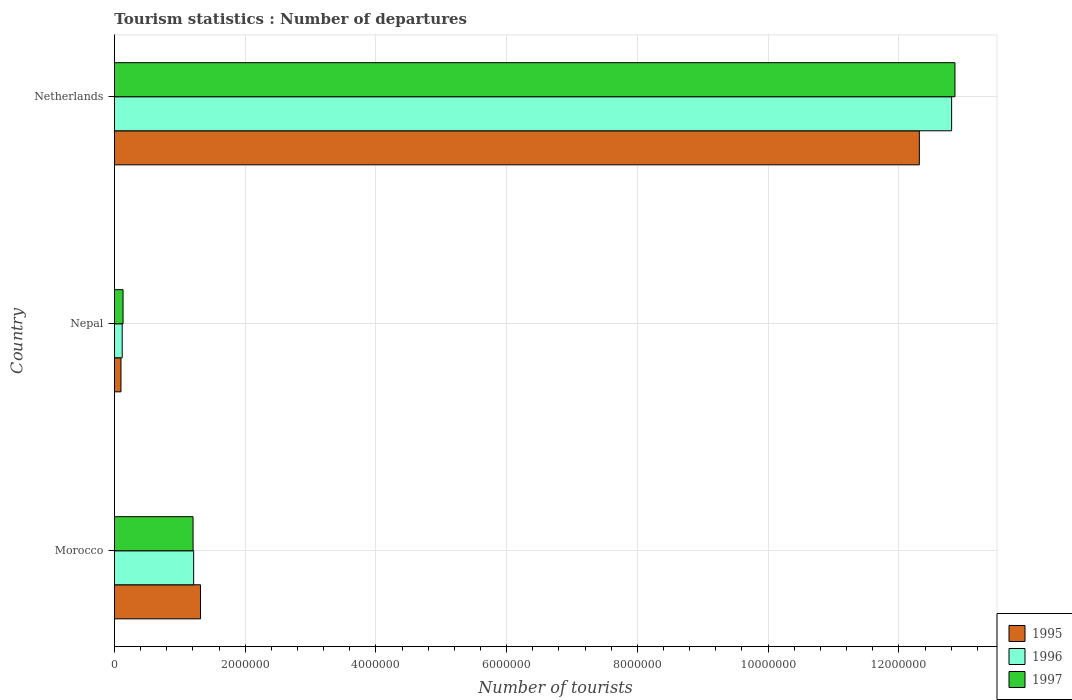Are the number of bars per tick equal to the number of legend labels?
Ensure brevity in your answer.  Yes. Are the number of bars on each tick of the Y-axis equal?
Offer a very short reply. Yes. What is the label of the 3rd group of bars from the top?
Provide a succinct answer. Morocco. In how many cases, is the number of bars for a given country not equal to the number of legend labels?
Provide a succinct answer. 0. What is the number of tourist departures in 1997 in Nepal?
Your answer should be compact. 1.32e+05. Across all countries, what is the maximum number of tourist departures in 1995?
Give a very brief answer. 1.23e+07. Across all countries, what is the minimum number of tourist departures in 1997?
Make the answer very short. 1.32e+05. In which country was the number of tourist departures in 1995 minimum?
Give a very brief answer. Nepal. What is the total number of tourist departures in 1996 in the graph?
Give a very brief answer. 1.41e+07. What is the difference between the number of tourist departures in 1997 in Morocco and that in Netherlands?
Give a very brief answer. -1.17e+07. What is the difference between the number of tourist departures in 1997 in Nepal and the number of tourist departures in 1995 in Morocco?
Provide a short and direct response. -1.18e+06. What is the average number of tourist departures in 1995 per country?
Provide a succinct answer. 4.58e+06. What is the difference between the number of tourist departures in 1996 and number of tourist departures in 1995 in Netherlands?
Ensure brevity in your answer.  4.94e+05. In how many countries, is the number of tourist departures in 1997 greater than 10800000 ?
Give a very brief answer. 1. What is the ratio of the number of tourist departures in 1996 in Nepal to that in Netherlands?
Keep it short and to the point. 0.01. Is the number of tourist departures in 1996 in Nepal less than that in Netherlands?
Offer a terse response. Yes. What is the difference between the highest and the second highest number of tourist departures in 1995?
Ensure brevity in your answer.  1.10e+07. What is the difference between the highest and the lowest number of tourist departures in 1996?
Offer a very short reply. 1.27e+07. In how many countries, is the number of tourist departures in 1996 greater than the average number of tourist departures in 1996 taken over all countries?
Keep it short and to the point. 1. What does the 3rd bar from the top in Nepal represents?
Offer a terse response. 1995. How many bars are there?
Provide a short and direct response. 9. Are the values on the major ticks of X-axis written in scientific E-notation?
Offer a very short reply. No. Does the graph contain any zero values?
Make the answer very short. No. Does the graph contain grids?
Your response must be concise. Yes. Where does the legend appear in the graph?
Your response must be concise. Bottom right. How many legend labels are there?
Ensure brevity in your answer.  3. What is the title of the graph?
Offer a terse response. Tourism statistics : Number of departures. What is the label or title of the X-axis?
Your response must be concise. Number of tourists. What is the label or title of the Y-axis?
Offer a terse response. Country. What is the Number of tourists of 1995 in Morocco?
Offer a very short reply. 1.32e+06. What is the Number of tourists in 1996 in Morocco?
Provide a succinct answer. 1.21e+06. What is the Number of tourists of 1997 in Morocco?
Offer a terse response. 1.20e+06. What is the Number of tourists of 1995 in Nepal?
Your response must be concise. 1.00e+05. What is the Number of tourists of 1996 in Nepal?
Your answer should be very brief. 1.19e+05. What is the Number of tourists of 1997 in Nepal?
Your answer should be compact. 1.32e+05. What is the Number of tourists in 1995 in Netherlands?
Provide a short and direct response. 1.23e+07. What is the Number of tourists in 1996 in Netherlands?
Provide a short and direct response. 1.28e+07. What is the Number of tourists in 1997 in Netherlands?
Give a very brief answer. 1.29e+07. Across all countries, what is the maximum Number of tourists in 1995?
Ensure brevity in your answer.  1.23e+07. Across all countries, what is the maximum Number of tourists of 1996?
Provide a succinct answer. 1.28e+07. Across all countries, what is the maximum Number of tourists of 1997?
Offer a very short reply. 1.29e+07. Across all countries, what is the minimum Number of tourists in 1996?
Offer a terse response. 1.19e+05. Across all countries, what is the minimum Number of tourists in 1997?
Provide a succinct answer. 1.32e+05. What is the total Number of tourists in 1995 in the graph?
Keep it short and to the point. 1.37e+07. What is the total Number of tourists in 1996 in the graph?
Your answer should be very brief. 1.41e+07. What is the total Number of tourists of 1997 in the graph?
Your answer should be very brief. 1.42e+07. What is the difference between the Number of tourists in 1995 in Morocco and that in Nepal?
Provide a succinct answer. 1.22e+06. What is the difference between the Number of tourists in 1996 in Morocco and that in Nepal?
Keep it short and to the point. 1.09e+06. What is the difference between the Number of tourists in 1997 in Morocco and that in Nepal?
Your response must be concise. 1.07e+06. What is the difference between the Number of tourists of 1995 in Morocco and that in Netherlands?
Your response must be concise. -1.10e+07. What is the difference between the Number of tourists in 1996 in Morocco and that in Netherlands?
Provide a succinct answer. -1.16e+07. What is the difference between the Number of tourists of 1997 in Morocco and that in Netherlands?
Your answer should be very brief. -1.17e+07. What is the difference between the Number of tourists of 1995 in Nepal and that in Netherlands?
Give a very brief answer. -1.22e+07. What is the difference between the Number of tourists in 1996 in Nepal and that in Netherlands?
Your answer should be compact. -1.27e+07. What is the difference between the Number of tourists of 1997 in Nepal and that in Netherlands?
Provide a succinct answer. -1.27e+07. What is the difference between the Number of tourists of 1995 in Morocco and the Number of tourists of 1996 in Nepal?
Provide a short and direct response. 1.20e+06. What is the difference between the Number of tourists in 1995 in Morocco and the Number of tourists in 1997 in Nepal?
Provide a short and direct response. 1.18e+06. What is the difference between the Number of tourists of 1996 in Morocco and the Number of tourists of 1997 in Nepal?
Your answer should be very brief. 1.08e+06. What is the difference between the Number of tourists of 1995 in Morocco and the Number of tourists of 1996 in Netherlands?
Offer a terse response. -1.15e+07. What is the difference between the Number of tourists of 1995 in Morocco and the Number of tourists of 1997 in Netherlands?
Offer a terse response. -1.15e+07. What is the difference between the Number of tourists of 1996 in Morocco and the Number of tourists of 1997 in Netherlands?
Your response must be concise. -1.16e+07. What is the difference between the Number of tourists of 1995 in Nepal and the Number of tourists of 1996 in Netherlands?
Your response must be concise. -1.27e+07. What is the difference between the Number of tourists in 1995 in Nepal and the Number of tourists in 1997 in Netherlands?
Give a very brief answer. -1.28e+07. What is the difference between the Number of tourists of 1996 in Nepal and the Number of tourists of 1997 in Netherlands?
Make the answer very short. -1.27e+07. What is the average Number of tourists in 1995 per country?
Provide a short and direct response. 4.58e+06. What is the average Number of tourists in 1996 per country?
Make the answer very short. 4.71e+06. What is the average Number of tourists of 1997 per country?
Make the answer very short. 4.73e+06. What is the difference between the Number of tourists in 1995 and Number of tourists in 1996 in Morocco?
Provide a short and direct response. 1.05e+05. What is the difference between the Number of tourists of 1995 and Number of tourists of 1997 in Morocco?
Provide a short and direct response. 1.14e+05. What is the difference between the Number of tourists of 1996 and Number of tourists of 1997 in Morocco?
Offer a very short reply. 9000. What is the difference between the Number of tourists in 1995 and Number of tourists in 1996 in Nepal?
Your answer should be compact. -1.90e+04. What is the difference between the Number of tourists of 1995 and Number of tourists of 1997 in Nepal?
Make the answer very short. -3.20e+04. What is the difference between the Number of tourists in 1996 and Number of tourists in 1997 in Nepal?
Offer a terse response. -1.30e+04. What is the difference between the Number of tourists of 1995 and Number of tourists of 1996 in Netherlands?
Offer a terse response. -4.94e+05. What is the difference between the Number of tourists in 1995 and Number of tourists in 1997 in Netherlands?
Provide a short and direct response. -5.45e+05. What is the difference between the Number of tourists in 1996 and Number of tourists in 1997 in Netherlands?
Your answer should be very brief. -5.10e+04. What is the ratio of the Number of tourists of 1995 in Morocco to that in Nepal?
Give a very brief answer. 13.17. What is the ratio of the Number of tourists in 1996 in Morocco to that in Nepal?
Provide a short and direct response. 10.18. What is the ratio of the Number of tourists of 1997 in Morocco to that in Nepal?
Keep it short and to the point. 9.11. What is the ratio of the Number of tourists in 1995 in Morocco to that in Netherlands?
Keep it short and to the point. 0.11. What is the ratio of the Number of tourists in 1996 in Morocco to that in Netherlands?
Give a very brief answer. 0.09. What is the ratio of the Number of tourists of 1997 in Morocco to that in Netherlands?
Offer a terse response. 0.09. What is the ratio of the Number of tourists of 1995 in Nepal to that in Netherlands?
Provide a short and direct response. 0.01. What is the ratio of the Number of tourists of 1996 in Nepal to that in Netherlands?
Provide a succinct answer. 0.01. What is the ratio of the Number of tourists in 1997 in Nepal to that in Netherlands?
Keep it short and to the point. 0.01. What is the difference between the highest and the second highest Number of tourists in 1995?
Keep it short and to the point. 1.10e+07. What is the difference between the highest and the second highest Number of tourists in 1996?
Your response must be concise. 1.16e+07. What is the difference between the highest and the second highest Number of tourists in 1997?
Offer a very short reply. 1.17e+07. What is the difference between the highest and the lowest Number of tourists in 1995?
Ensure brevity in your answer.  1.22e+07. What is the difference between the highest and the lowest Number of tourists in 1996?
Your answer should be compact. 1.27e+07. What is the difference between the highest and the lowest Number of tourists of 1997?
Ensure brevity in your answer.  1.27e+07. 